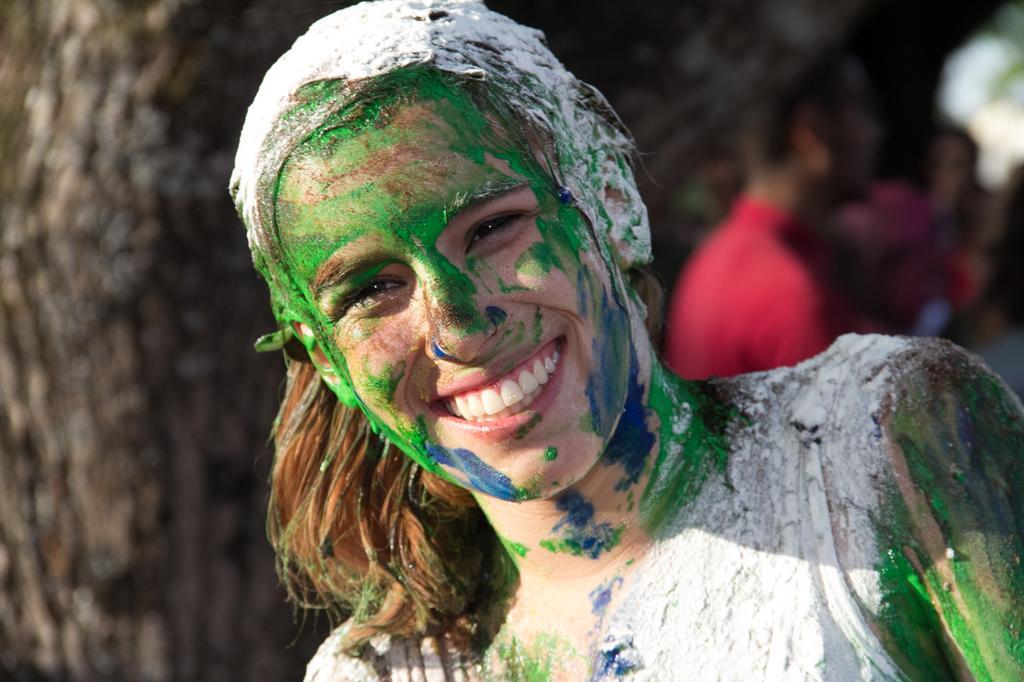Could you give a brief overview of what you see in this image? Here I can see a woman painted some colors on her face, smiling and giving pose for the picture. In the background, I can see some more people. 